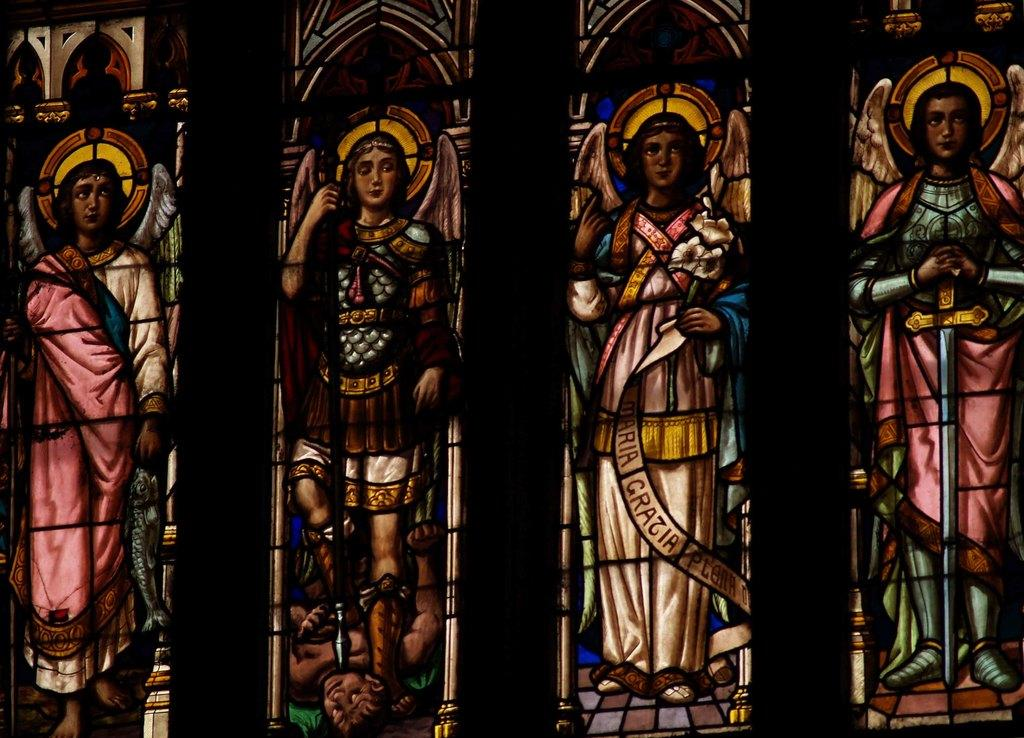What is depicted in the painting that is visible in the image? There is a painting of a person in the image. What can be seen on the glasses in the image? There are objects visible on the glasses in the image. What type of pipe is the person smoking in the image? There is no pipe or smoking depicted in the image; it features a painting of a person and objects on glasses. What is the person's belief system in the image? There is no information about the person's belief system in the image. 